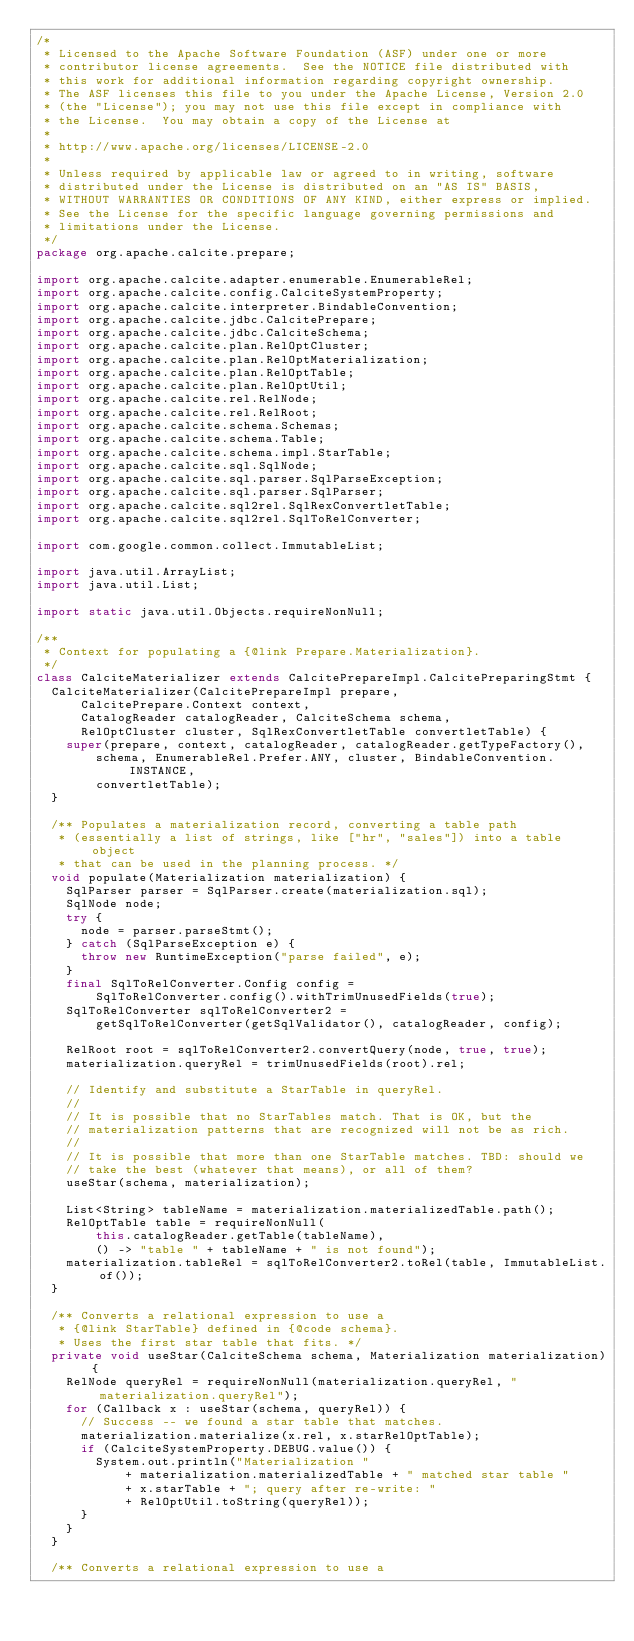Convert code to text. <code><loc_0><loc_0><loc_500><loc_500><_Java_>/*
 * Licensed to the Apache Software Foundation (ASF) under one or more
 * contributor license agreements.  See the NOTICE file distributed with
 * this work for additional information regarding copyright ownership.
 * The ASF licenses this file to you under the Apache License, Version 2.0
 * (the "License"); you may not use this file except in compliance with
 * the License.  You may obtain a copy of the License at
 *
 * http://www.apache.org/licenses/LICENSE-2.0
 *
 * Unless required by applicable law or agreed to in writing, software
 * distributed under the License is distributed on an "AS IS" BASIS,
 * WITHOUT WARRANTIES OR CONDITIONS OF ANY KIND, either express or implied.
 * See the License for the specific language governing permissions and
 * limitations under the License.
 */
package org.apache.calcite.prepare;

import org.apache.calcite.adapter.enumerable.EnumerableRel;
import org.apache.calcite.config.CalciteSystemProperty;
import org.apache.calcite.interpreter.BindableConvention;
import org.apache.calcite.jdbc.CalcitePrepare;
import org.apache.calcite.jdbc.CalciteSchema;
import org.apache.calcite.plan.RelOptCluster;
import org.apache.calcite.plan.RelOptMaterialization;
import org.apache.calcite.plan.RelOptTable;
import org.apache.calcite.plan.RelOptUtil;
import org.apache.calcite.rel.RelNode;
import org.apache.calcite.rel.RelRoot;
import org.apache.calcite.schema.Schemas;
import org.apache.calcite.schema.Table;
import org.apache.calcite.schema.impl.StarTable;
import org.apache.calcite.sql.SqlNode;
import org.apache.calcite.sql.parser.SqlParseException;
import org.apache.calcite.sql.parser.SqlParser;
import org.apache.calcite.sql2rel.SqlRexConvertletTable;
import org.apache.calcite.sql2rel.SqlToRelConverter;

import com.google.common.collect.ImmutableList;

import java.util.ArrayList;
import java.util.List;

import static java.util.Objects.requireNonNull;

/**
 * Context for populating a {@link Prepare.Materialization}.
 */
class CalciteMaterializer extends CalcitePrepareImpl.CalcitePreparingStmt {
  CalciteMaterializer(CalcitePrepareImpl prepare,
      CalcitePrepare.Context context,
      CatalogReader catalogReader, CalciteSchema schema,
      RelOptCluster cluster, SqlRexConvertletTable convertletTable) {
    super(prepare, context, catalogReader, catalogReader.getTypeFactory(),
        schema, EnumerableRel.Prefer.ANY, cluster, BindableConvention.INSTANCE,
        convertletTable);
  }

  /** Populates a materialization record, converting a table path
   * (essentially a list of strings, like ["hr", "sales"]) into a table object
   * that can be used in the planning process. */
  void populate(Materialization materialization) {
    SqlParser parser = SqlParser.create(materialization.sql);
    SqlNode node;
    try {
      node = parser.parseStmt();
    } catch (SqlParseException e) {
      throw new RuntimeException("parse failed", e);
    }
    final SqlToRelConverter.Config config =
        SqlToRelConverter.config().withTrimUnusedFields(true);
    SqlToRelConverter sqlToRelConverter2 =
        getSqlToRelConverter(getSqlValidator(), catalogReader, config);

    RelRoot root = sqlToRelConverter2.convertQuery(node, true, true);
    materialization.queryRel = trimUnusedFields(root).rel;

    // Identify and substitute a StarTable in queryRel.
    //
    // It is possible that no StarTables match. That is OK, but the
    // materialization patterns that are recognized will not be as rich.
    //
    // It is possible that more than one StarTable matches. TBD: should we
    // take the best (whatever that means), or all of them?
    useStar(schema, materialization);

    List<String> tableName = materialization.materializedTable.path();
    RelOptTable table = requireNonNull(
        this.catalogReader.getTable(tableName),
        () -> "table " + tableName + " is not found");
    materialization.tableRel = sqlToRelConverter2.toRel(table, ImmutableList.of());
  }

  /** Converts a relational expression to use a
   * {@link StarTable} defined in {@code schema}.
   * Uses the first star table that fits. */
  private void useStar(CalciteSchema schema, Materialization materialization) {
    RelNode queryRel = requireNonNull(materialization.queryRel, "materialization.queryRel");
    for (Callback x : useStar(schema, queryRel)) {
      // Success -- we found a star table that matches.
      materialization.materialize(x.rel, x.starRelOptTable);
      if (CalciteSystemProperty.DEBUG.value()) {
        System.out.println("Materialization "
            + materialization.materializedTable + " matched star table "
            + x.starTable + "; query after re-write: "
            + RelOptUtil.toString(queryRel));
      }
    }
  }

  /** Converts a relational expression to use a</code> 